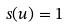Convert formula to latex. <formula><loc_0><loc_0><loc_500><loc_500>s ( u ) = 1</formula> 